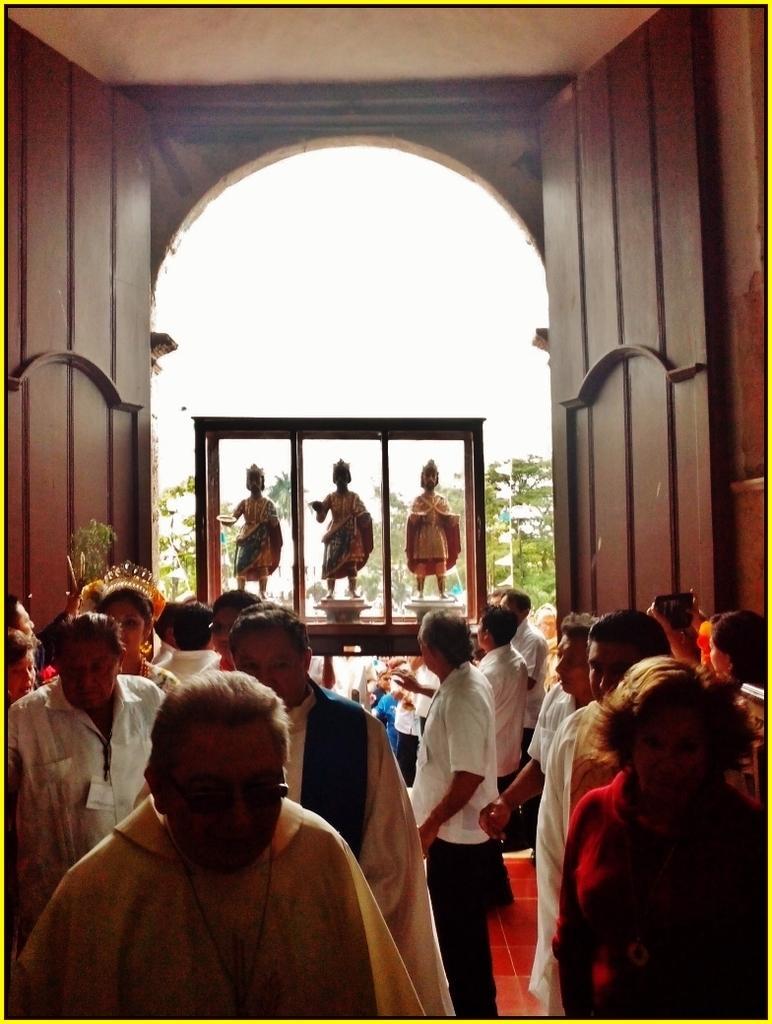Could you give a brief overview of what you see in this image? Here in this picture, in the front we can see a group of men and women standing and walking on the floor and in the middle we can see statues present in a wooden box and beside that on either side we can see wooden door present and in the far we can see plants and trees present and we can see the sky is clear. 